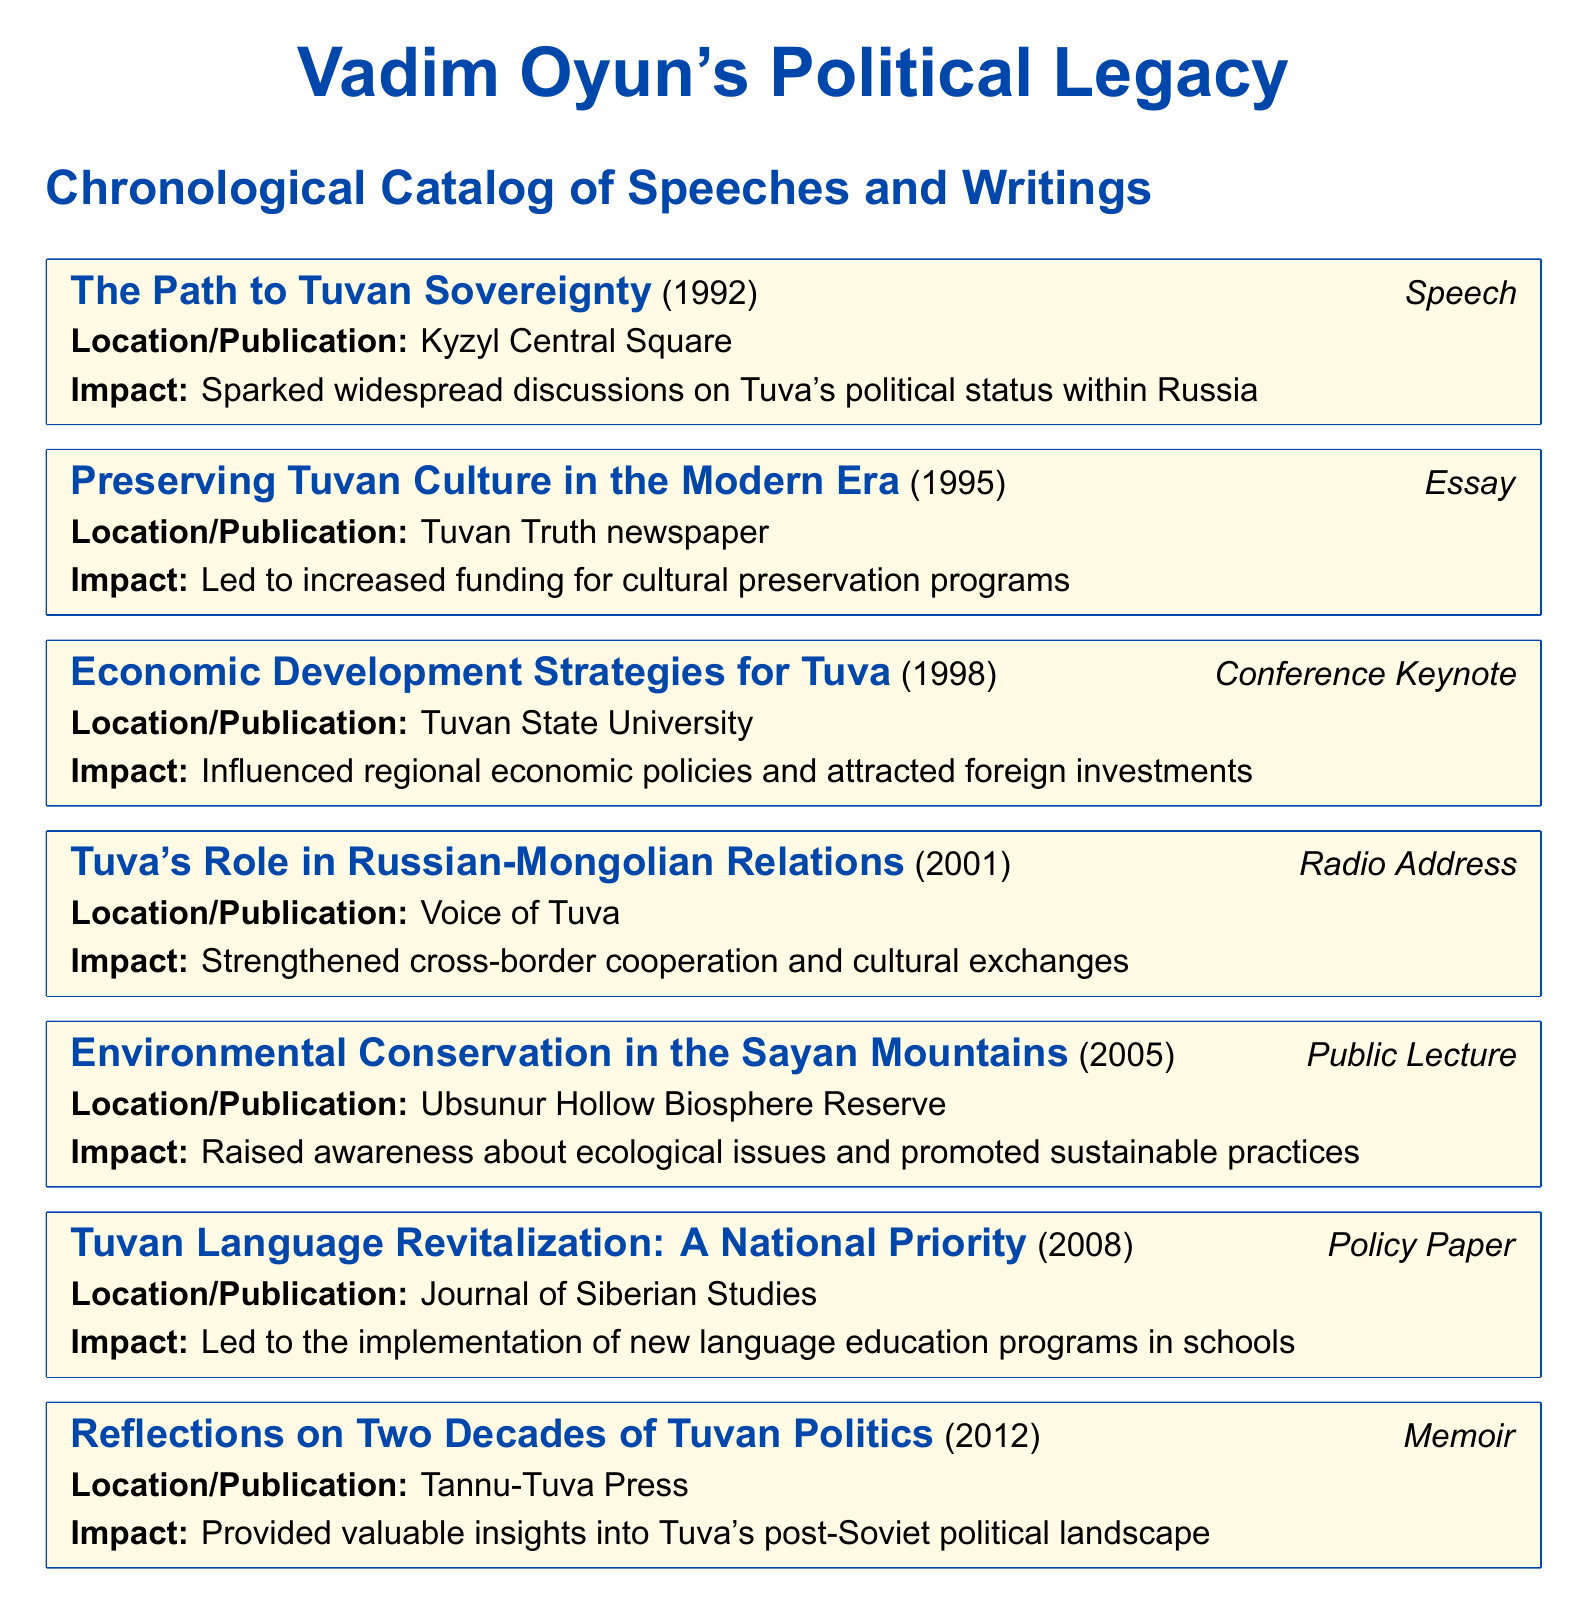What is the title of Vadim Oyun's 1992 speech? The title is the first line of the entry under the year 1992, which is "The Path to Tuvan Sovereignty."
Answer: The Path to Tuvan Sovereignty In which location was "Economic Development Strategies for Tuva" presented? The location is specified in the entry for 1998, which mentions "Tuvan State University."
Answer: Tuvan State University What year did Vadim Oyun write about preserving Tuvan culture? The year is shown in the entry for the essay titled "Preserving Tuvan Culture in the Modern Era," which is 1995.
Answer: 1995 What was one impact of the 2005 public lecture? The impact is detailed in the entry for 2005, highlighting that it "raised awareness about ecological issues and promoted sustainable practices."
Answer: Raised awareness about ecological issues How many entries are related to language revitalization? The catalog only mentions one specific entry regarding language, found in the 2008 policy paper.
Answer: One Which entry discusses Tuva's relationship with Mongolia? The entry that addresses this topic is titled "Tuva's Role in Russian-Mongolian Relations" from 2001.
Answer: Tuva's Role in Russian-Mongolian Relations What type of document is "Reflections on Two Decades of Tuvan Politics"? The 2012 entry specifies that it is a memoir, as presented in the subtitle.
Answer: Memoir In what year was the policy paper on language revitalization published? The entry for this paper indicates it was published in 2008.
Answer: 2008 What form of media did Vadim Oyun use for his address on Russian-Mongolian Relations? The entry states that the address was delivered via "Radio Address."
Answer: Radio Address Which speech had an impact on funding for cultural preservation? The 1995 essay "Preserving Tuvan Culture in the Modern Era" is noted for this impact.
Answer: Preserving Tuvan Culture in the Modern Era 